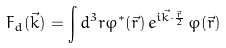<formula> <loc_0><loc_0><loc_500><loc_500>F _ { d } ( \vec { k } ) = \int d ^ { 3 } r \varphi ^ { * } ( \vec { r } ) \, e ^ { i \vec { k } \cdot \frac { \vec { r } } { 2 } } \, \varphi ( \vec { r } )</formula> 